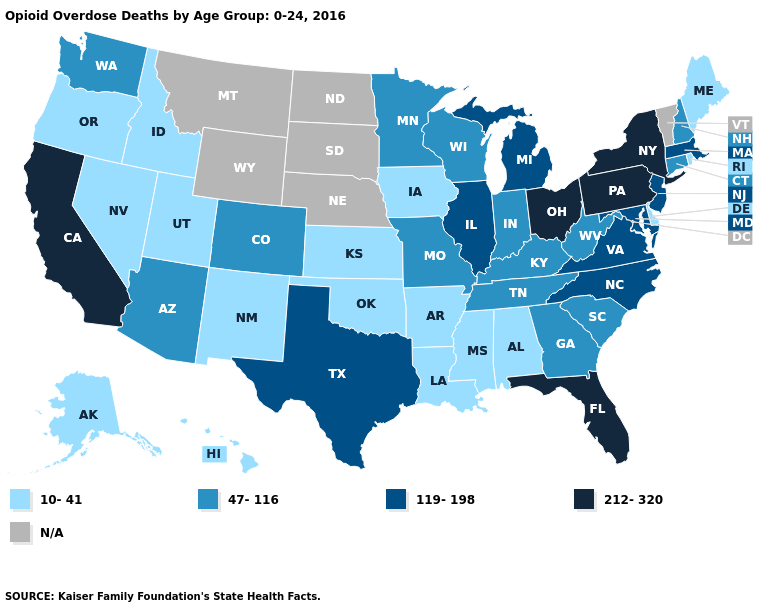Name the states that have a value in the range 119-198?
Answer briefly. Illinois, Maryland, Massachusetts, Michigan, New Jersey, North Carolina, Texas, Virginia. Which states have the highest value in the USA?
Be succinct. California, Florida, New York, Ohio, Pennsylvania. What is the value of Arizona?
Give a very brief answer. 47-116. What is the value of Colorado?
Keep it brief. 47-116. What is the lowest value in the USA?
Be succinct. 10-41. Does the first symbol in the legend represent the smallest category?
Answer briefly. Yes. Does Florida have the highest value in the South?
Give a very brief answer. Yes. What is the highest value in states that border South Dakota?
Keep it brief. 47-116. Does the first symbol in the legend represent the smallest category?
Be succinct. Yes. What is the value of Alaska?
Give a very brief answer. 10-41. Does Georgia have the highest value in the USA?
Write a very short answer. No. What is the value of Massachusetts?
Answer briefly. 119-198. What is the value of Wyoming?
Short answer required. N/A. 